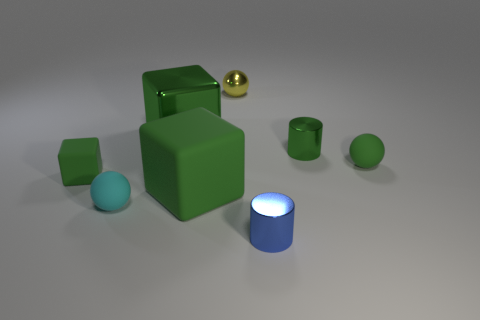There is a yellow sphere; are there any shiny balls to the right of it?
Provide a succinct answer. No. What size is the green metal block?
Your answer should be very brief. Large. There is a green thing that is the same shape as the tiny blue object; what size is it?
Your response must be concise. Small. What number of tiny green objects are to the left of the yellow metal ball that is behind the small cyan rubber thing?
Provide a short and direct response. 1. Are the tiny sphere that is in front of the green ball and the big green cube that is behind the tiny green cube made of the same material?
Provide a short and direct response. No. What number of yellow things are the same shape as the tiny cyan thing?
Provide a short and direct response. 1. What number of tiny balls are the same color as the tiny block?
Make the answer very short. 1. There is a large green metal thing that is behind the small green matte cube; does it have the same shape as the tiny shiny object that is in front of the tiny green matte cube?
Offer a terse response. No. How many green matte cubes are in front of the green matte object on the left side of the large green thing that is behind the small green rubber sphere?
Your answer should be compact. 1. What is the material of the small ball that is in front of the rubber sphere to the right of the cylinder in front of the green matte sphere?
Provide a short and direct response. Rubber. 